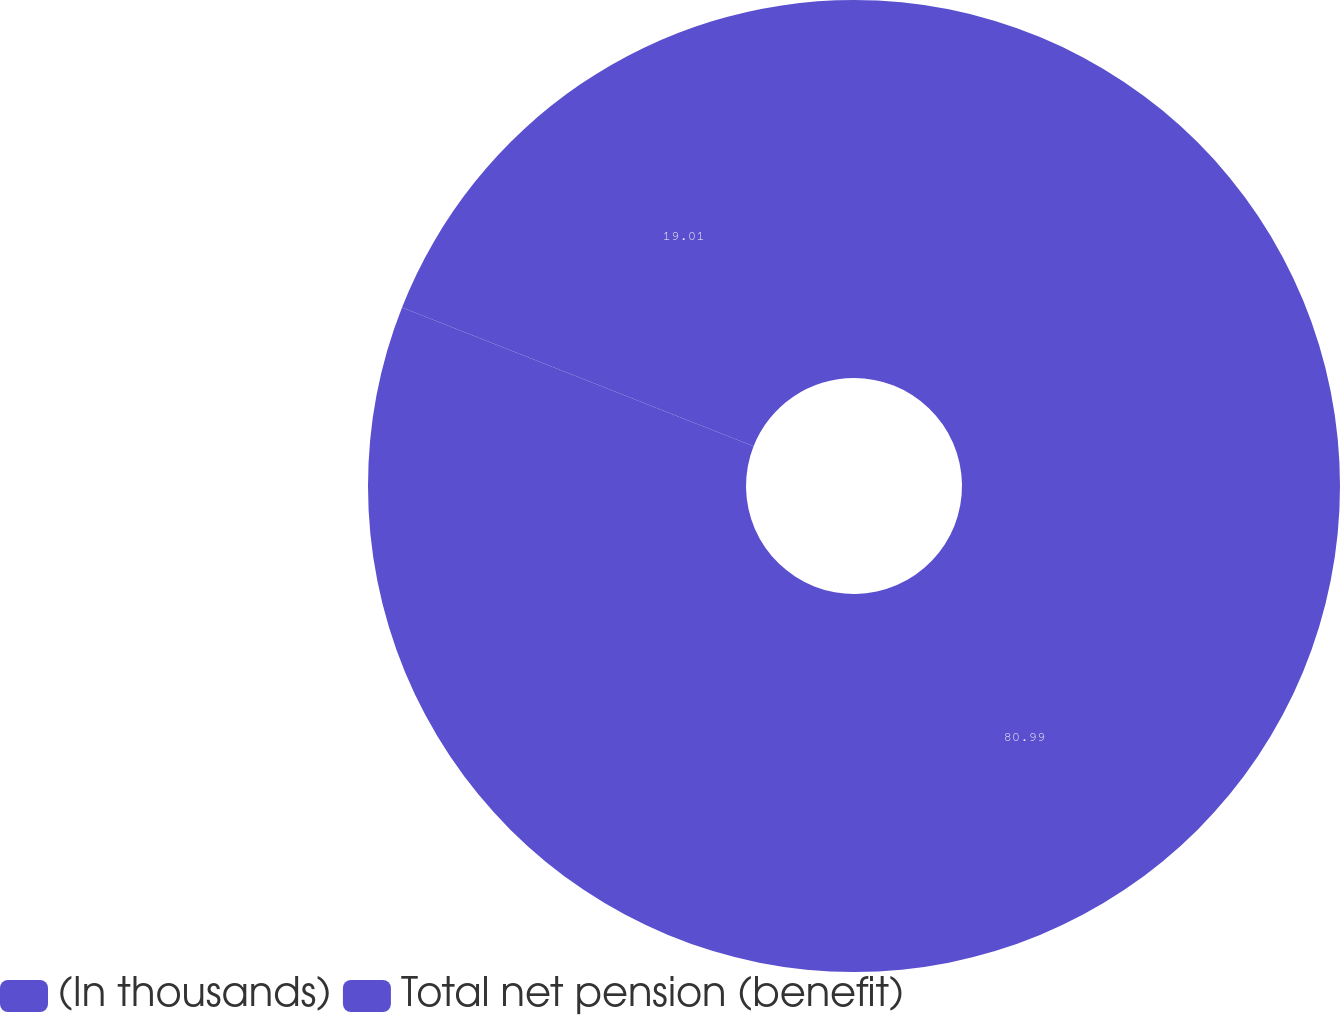Convert chart to OTSL. <chart><loc_0><loc_0><loc_500><loc_500><pie_chart><fcel>(In thousands)<fcel>Total net pension (benefit)<nl><fcel>80.99%<fcel>19.01%<nl></chart> 